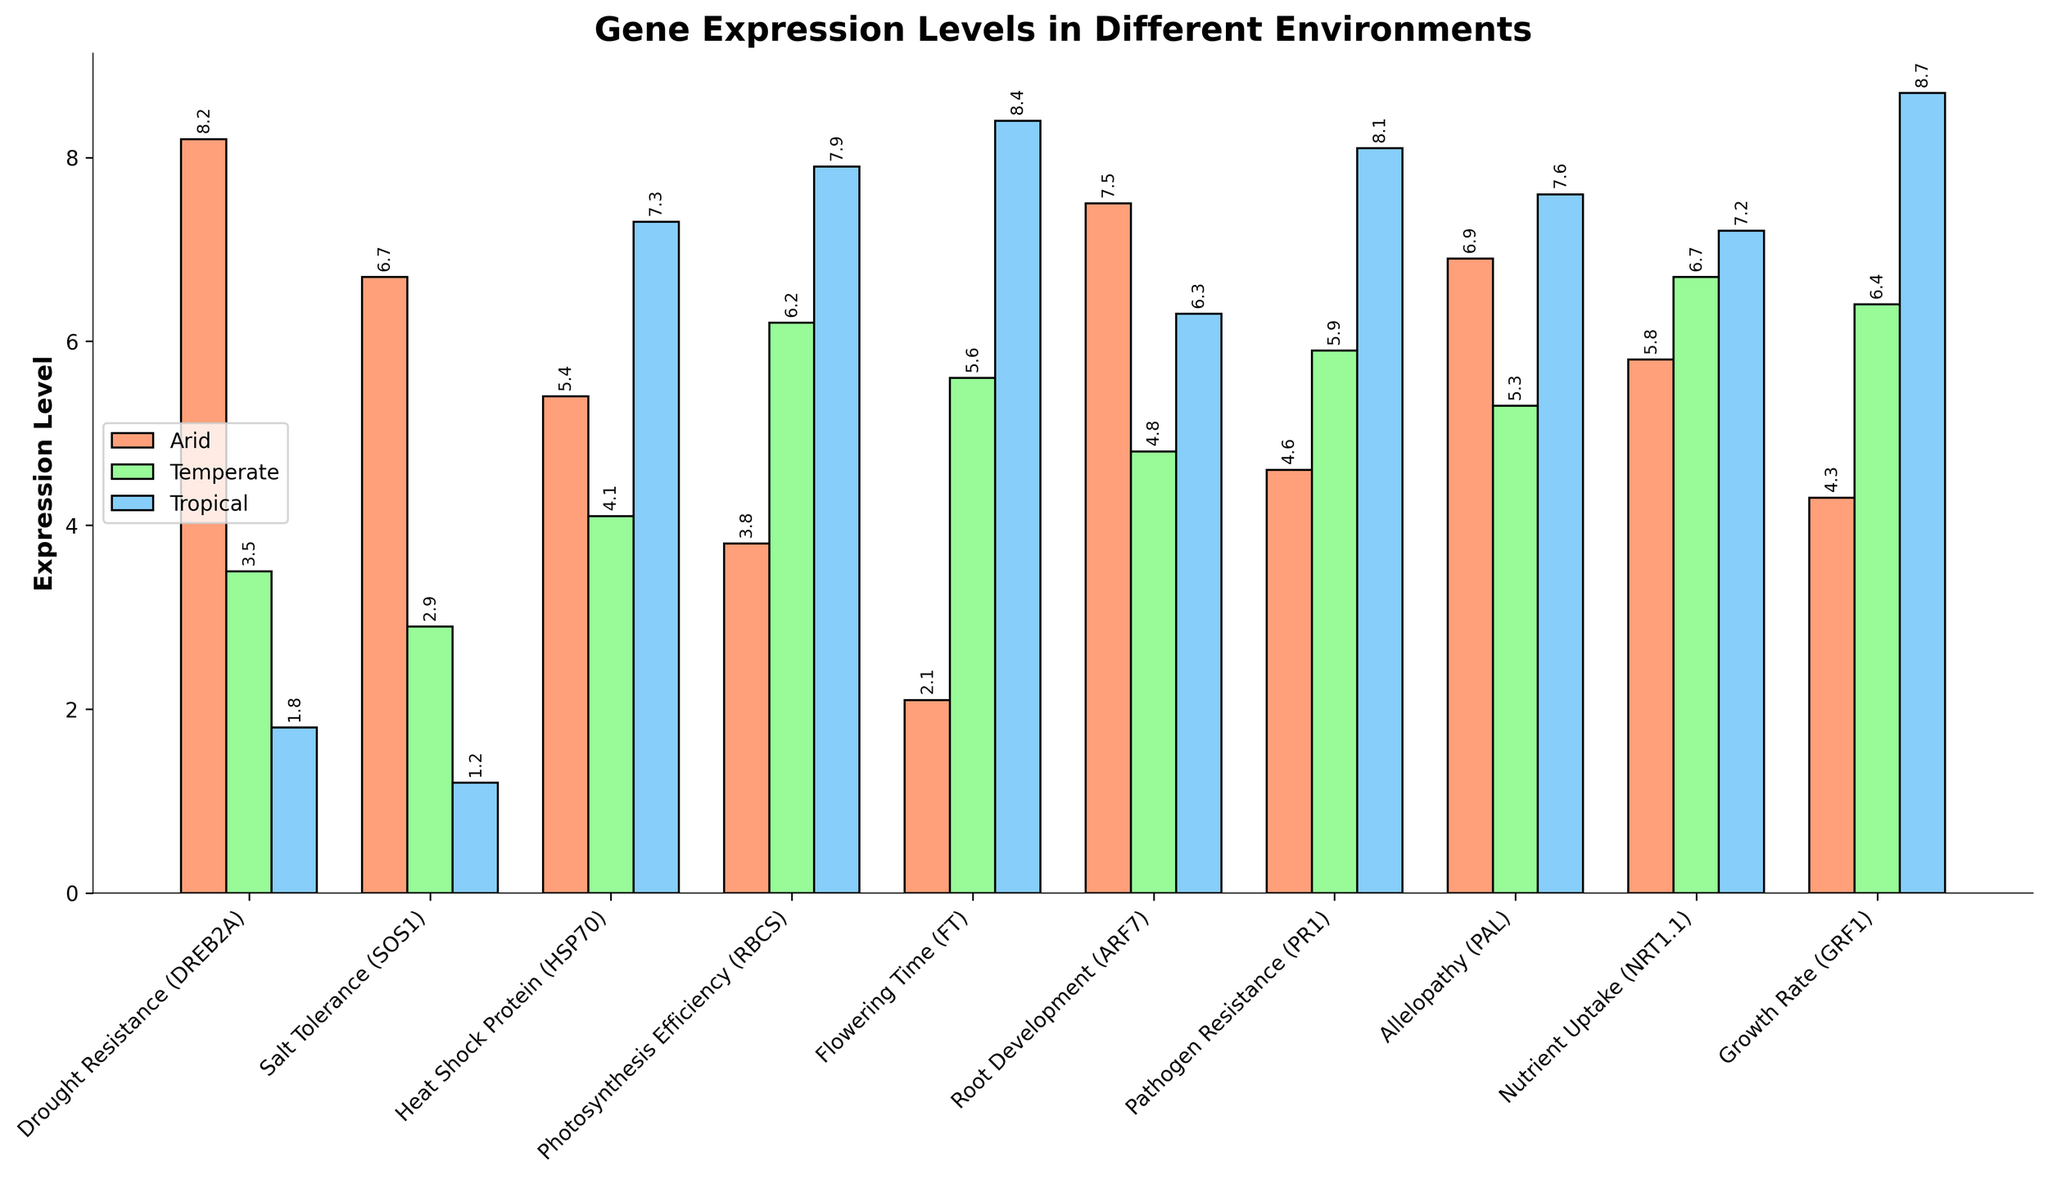Which gene has the highest expression level in the arid environment? By looking at the height of the bars representing the arid environment, the gene "Drought Resistance (DREB2A)" has the tallest bar, indicating the highest expression level.
Answer: Drought Resistance (DREB2A) Which environment shows the lowest expression level for the gene 'Salt Tolerance (SOS1)'? Among the three bars for "Salt Tolerance (SOS1)", the tropical environment bar is the shortest, indicating the lowest expression level.
Answer: Tropical Environment What is the difference in expression levels of the 'Heat Shock Protein (HSP70)' gene between temperate and tropical environments? The expression level in the temperate environment is 4.1, and in the tropical environment, it is 7.3. The difference is calculated as 7.3 - 4.1 = 3.2.
Answer: 3.2 Which gene's expression levels are closest between the arid and temperate environments? By inspecting the heights of the bars for each gene between the arid and temperate environments, "Heat Shock Protein (HSP70)" shows the closest expression levels with values of 5.4 and 4.1, respectively.
Answer: Heat Shock Protein (HSP70) Does the gene 'Root Development (ARF7)' show a higher expression level in the temperate environment compared to the 'Nutrient Uptake (NRT1.1)' gene in the same environment? The expression level of "Root Development (ARF7)" in the temperate environment is 4.8, while "Nutrient Uptake (NRT1.1)" is 6.7. Thus, "Root Development" is lower than "Nutrient Uptake."
Answer: No What is the average expression level of 'Flowering Time (FT)' across all three environments? The expression levels in arid, temperate, and tropical environments are 2.1, 5.6, and 8.4, respectively. The average is calculated as (2.1 + 5.6 + 8.4) / 3 ≈ 5.37.
Answer: 5.37 Which environment has the highest overall gene expression level for all genes combined? Sum the expression levels for each environment: Arid (8.2+6.7+5.4+3.8+2.1+7.5+4.6+6.9+5.8+4.3=55.3), Temperate (3.5+2.9+4.1+6.2+5.6+4.8+5.9+5.3+6.7+6.4=51.4), Tropical (1.8+1.2+7.3+7.9+8.4+6.3+8.1+7.6+7.2+8.7=64.5). The tropical environment has the highest sum.
Answer: Tropical Environment Which gene expression sees the largest increase when moving from the arid to the tropical environment? Inspect the difference in height between the arid and tropical environment bars for each gene. "Growth Rate (GRF1)" shows the largest increase: 8.7 - 4.3 = 4.4.
Answer: Growth Rate (GRF1) How many genes have an expression level greater than 5 in the temperate environment? Count the genes with heights greater than 5 in the temperate environment: "Photosynthesis Efficiency (RBCS)", "Flowering Time (FT)", "Pathogen Resistance (PR1)", "Allelopathy (PAL)", "Nutrient Uptake (NRT1.1)", and "Growth Rate (GRF1)". A total of 6 genes.
Answer: 6 